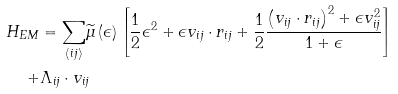Convert formula to latex. <formula><loc_0><loc_0><loc_500><loc_500>H _ { E M } & = \underset { \left \langle i j \right \rangle } { \sum } \widetilde { \mu } \left ( \epsilon \right ) \left [ \frac { 1 } { 2 } \epsilon ^ { 2 } + \epsilon v _ { i j } \cdot r _ { i j } + \frac { 1 } { 2 } \frac { \left ( v _ { i j } \cdot r _ { i j } \right ) ^ { 2 } + \epsilon v _ { i j } ^ { 2 } } { 1 + \epsilon } \right ] \\ + & \Lambda _ { i j } \cdot v _ { i j }</formula> 